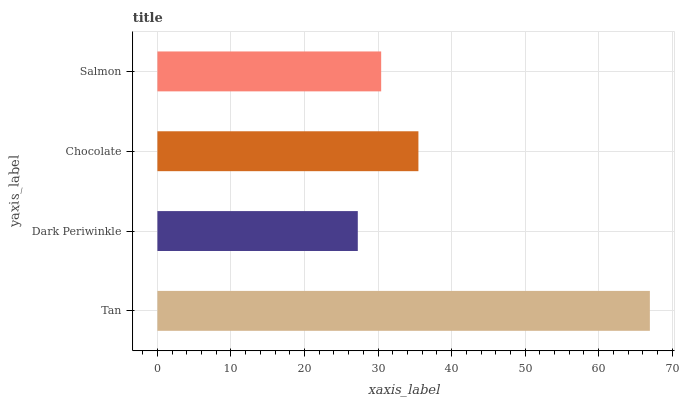Is Dark Periwinkle the minimum?
Answer yes or no. Yes. Is Tan the maximum?
Answer yes or no. Yes. Is Chocolate the minimum?
Answer yes or no. No. Is Chocolate the maximum?
Answer yes or no. No. Is Chocolate greater than Dark Periwinkle?
Answer yes or no. Yes. Is Dark Periwinkle less than Chocolate?
Answer yes or no. Yes. Is Dark Periwinkle greater than Chocolate?
Answer yes or no. No. Is Chocolate less than Dark Periwinkle?
Answer yes or no. No. Is Chocolate the high median?
Answer yes or no. Yes. Is Salmon the low median?
Answer yes or no. Yes. Is Salmon the high median?
Answer yes or no. No. Is Chocolate the low median?
Answer yes or no. No. 